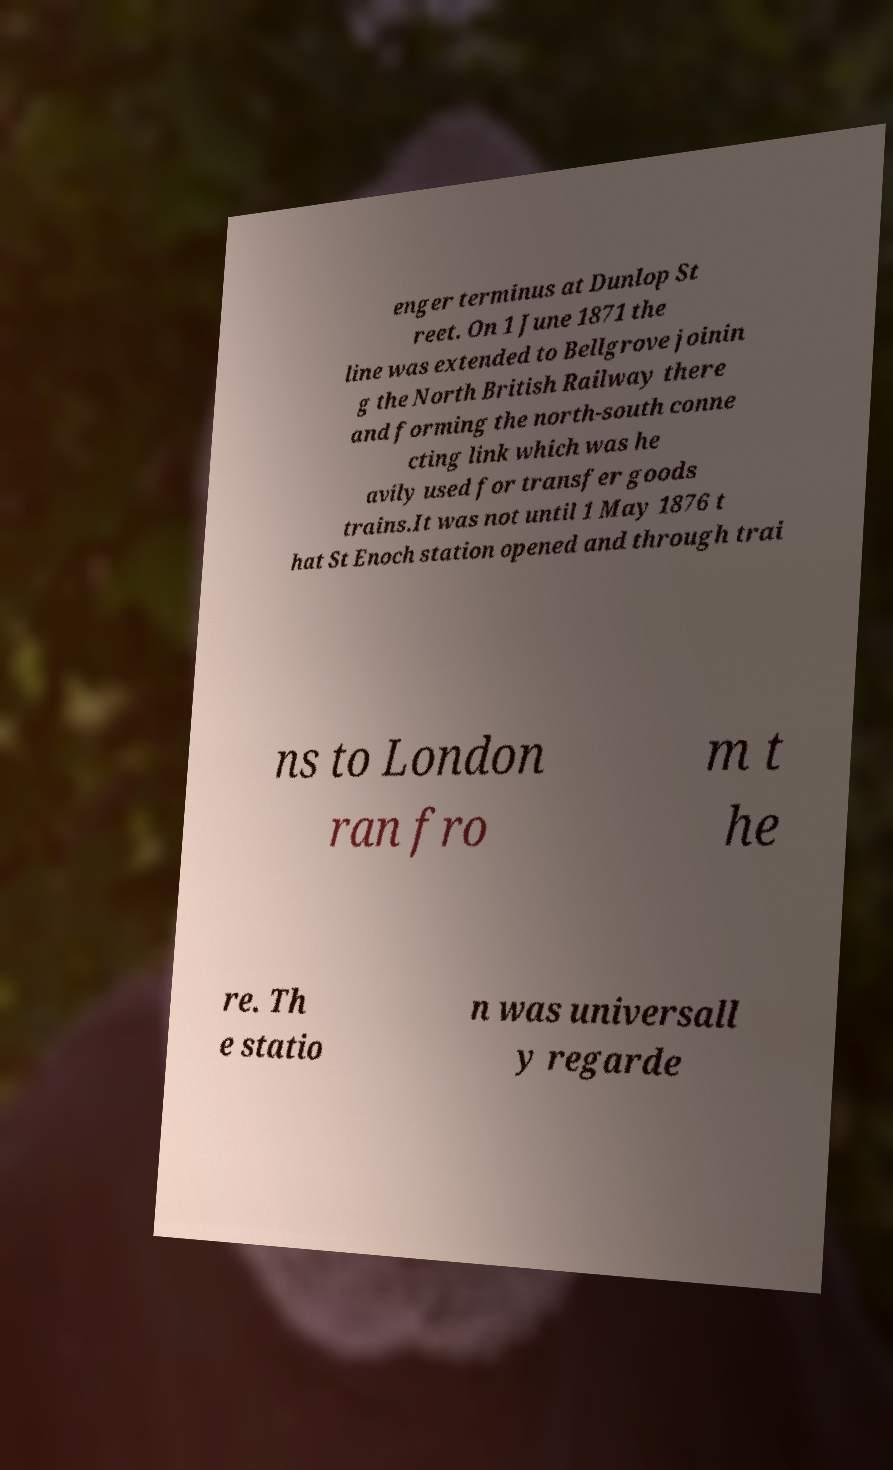Can you accurately transcribe the text from the provided image for me? enger terminus at Dunlop St reet. On 1 June 1871 the line was extended to Bellgrove joinin g the North British Railway there and forming the north-south conne cting link which was he avily used for transfer goods trains.It was not until 1 May 1876 t hat St Enoch station opened and through trai ns to London ran fro m t he re. Th e statio n was universall y regarde 